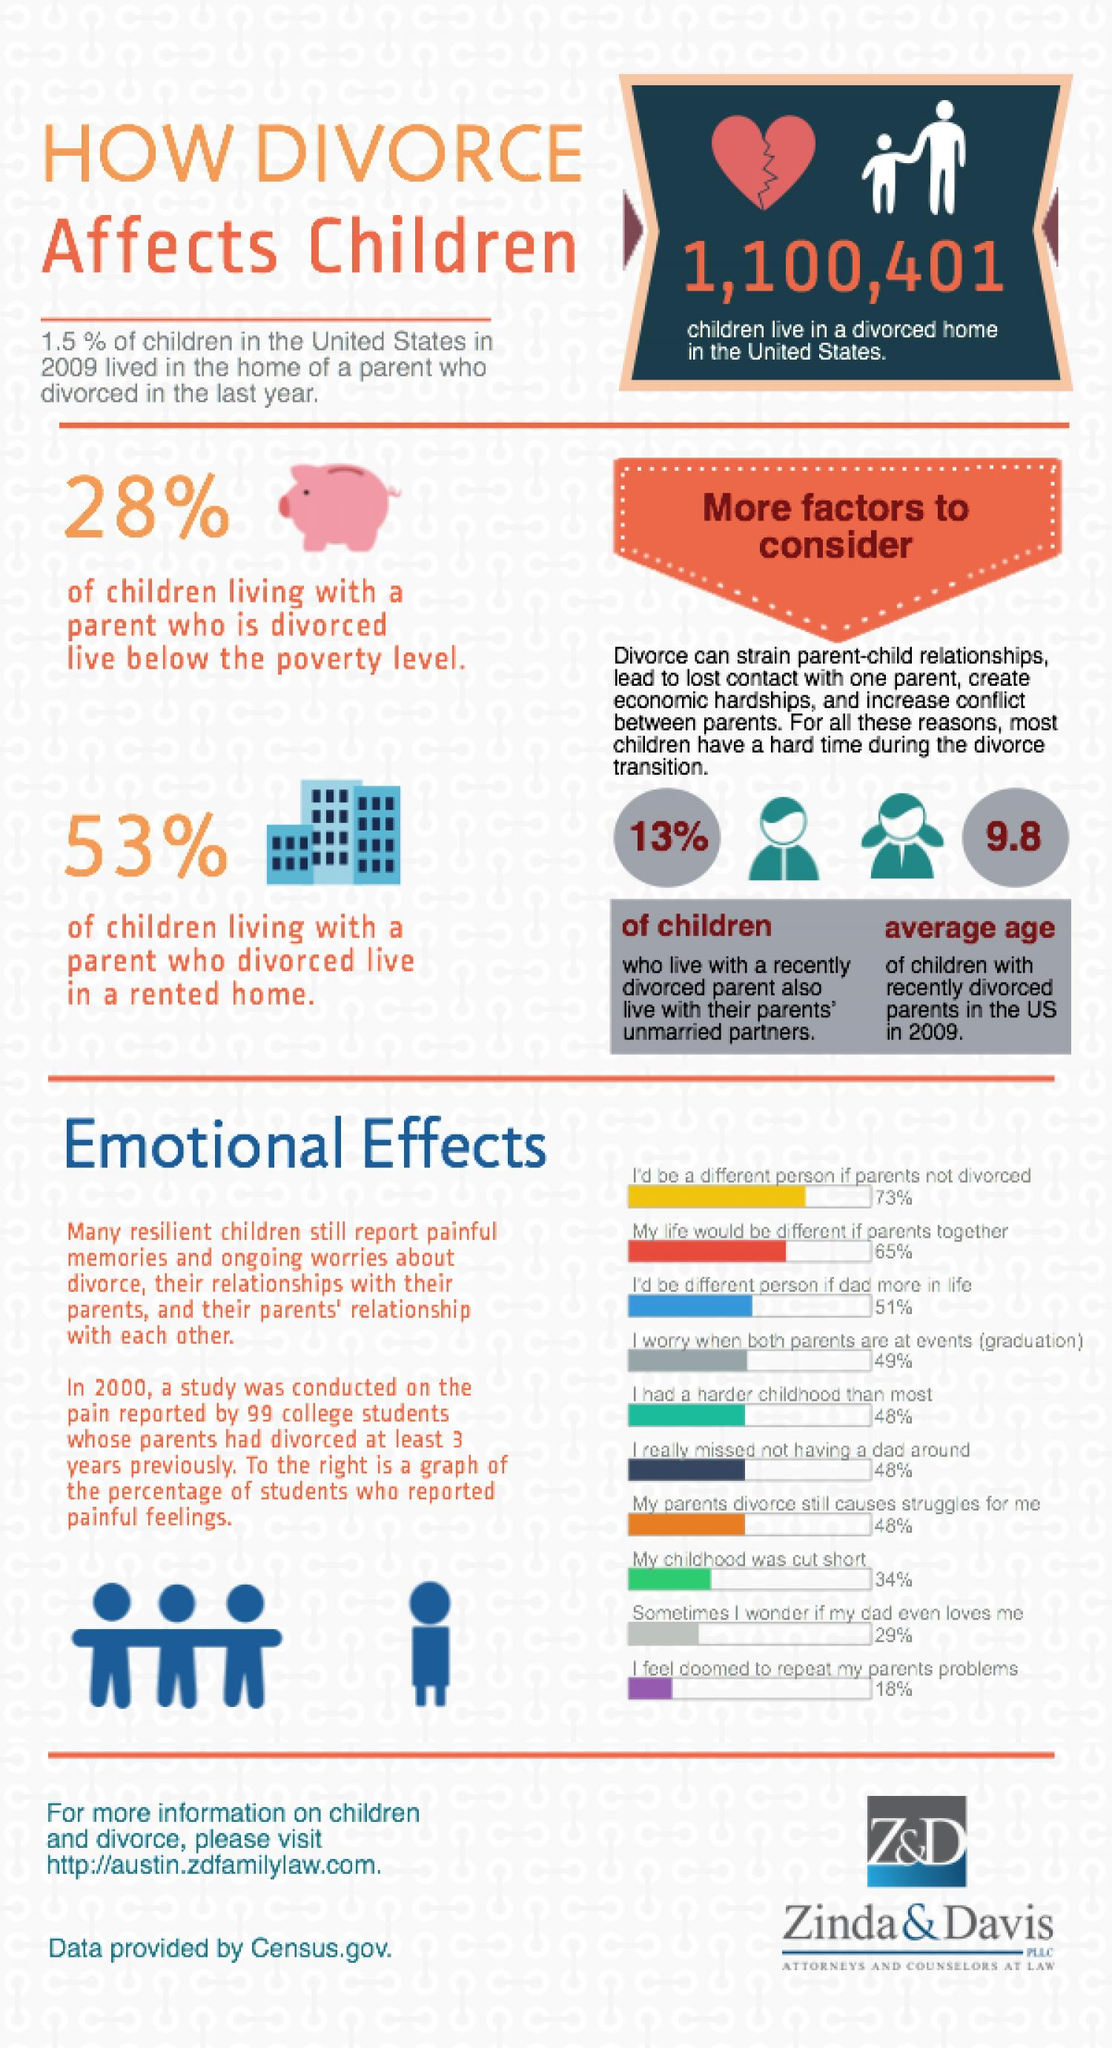Mention a couple of crucial points in this snapshot. According to recent data, a staggering 72% of children living with a parent who is divorced live above the poverty level, which is a clear indication of the economic struggles faced by families in these circumstances. According to a recent study, 47% of children who live with a parent who has divorced currently reside in their own home. 